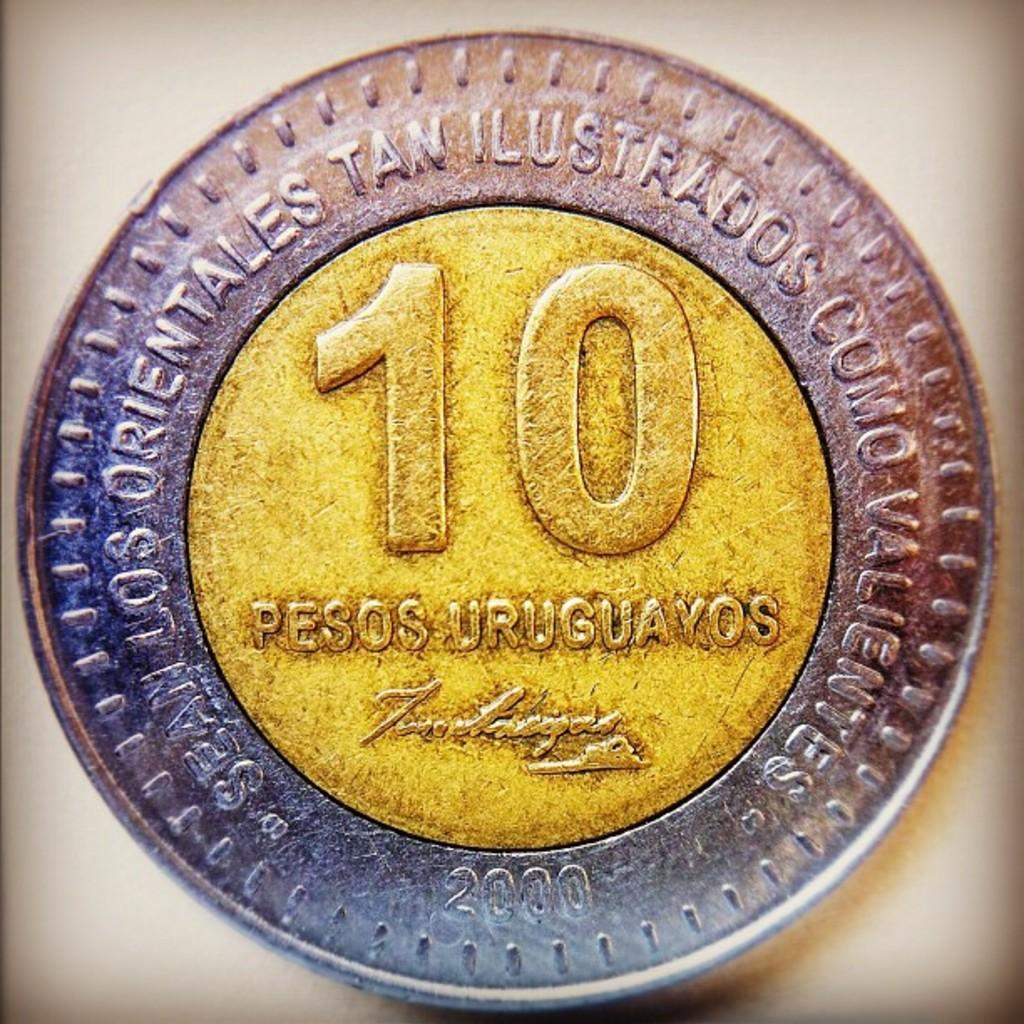<image>
Create a compact narrative representing the image presented. A coin that says "10 PESOS URUGUAYOS" on the face. 